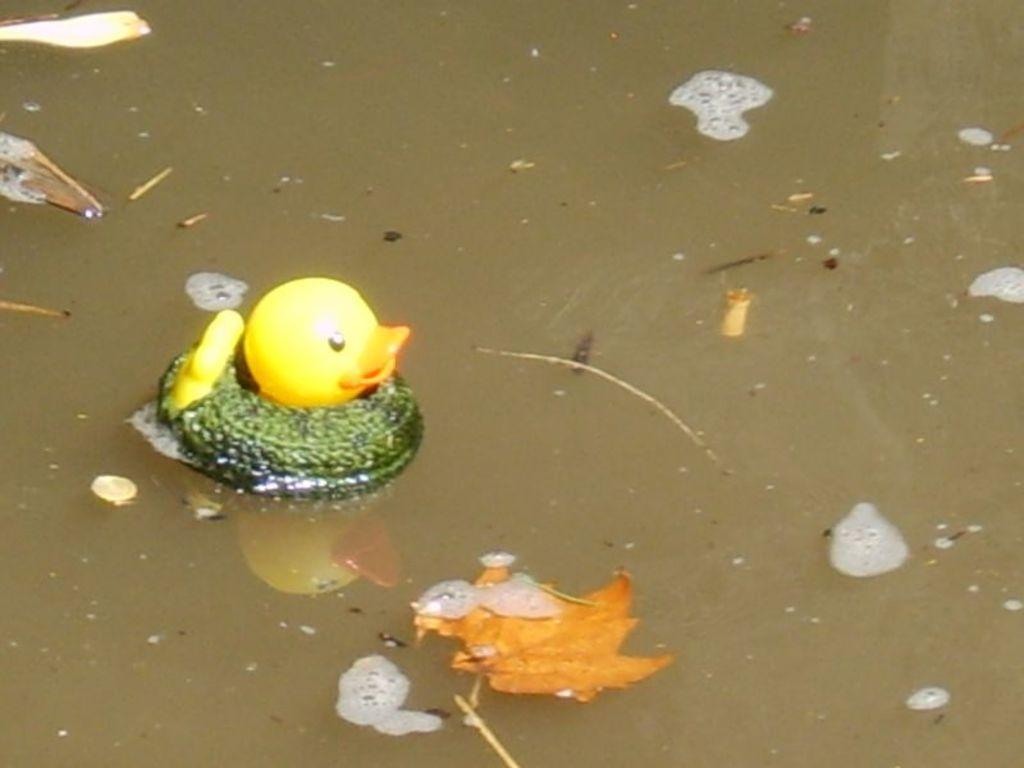Can you describe this image briefly? In this image we can see there is a small duckling floating in the water, behind that there are so many dust particles. 